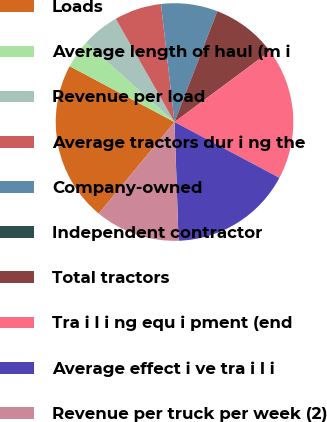Convert chart. <chart><loc_0><loc_0><loc_500><loc_500><pie_chart><fcel>Loads<fcel>Average length of haul (m i<fcel>Revenue per load<fcel>Average tractors dur i ng the<fcel>Company-owned<fcel>Independent contractor<fcel>Total tractors<fcel>Tra i l i ng equ i pment (end<fcel>Average effect i ve tra i l i<fcel>Revenue per truck per week (2)<nl><fcel>21.79%<fcel>3.85%<fcel>5.13%<fcel>6.41%<fcel>7.69%<fcel>0.0%<fcel>8.97%<fcel>17.95%<fcel>16.67%<fcel>11.54%<nl></chart> 